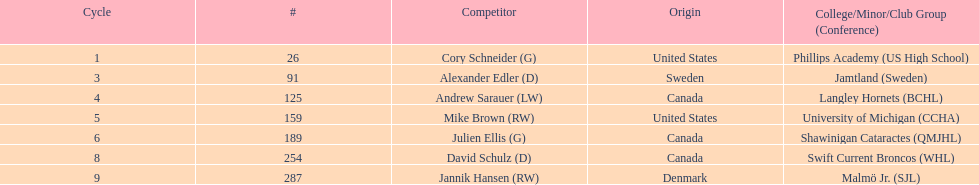What number of players have canada listed as their nationality? 3. 